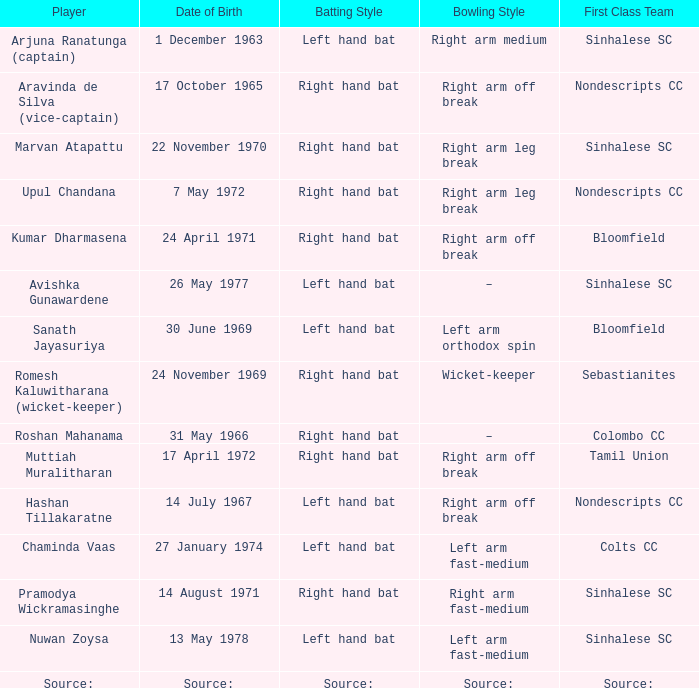What premier group does sanath jayasuriya compete for? Bloomfield. 